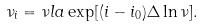Convert formula to latex. <formula><loc_0><loc_0><loc_500><loc_500>\nu _ { i } = \nu l a \exp [ ( i - i _ { 0 } ) \Delta \ln \nu ] .</formula> 